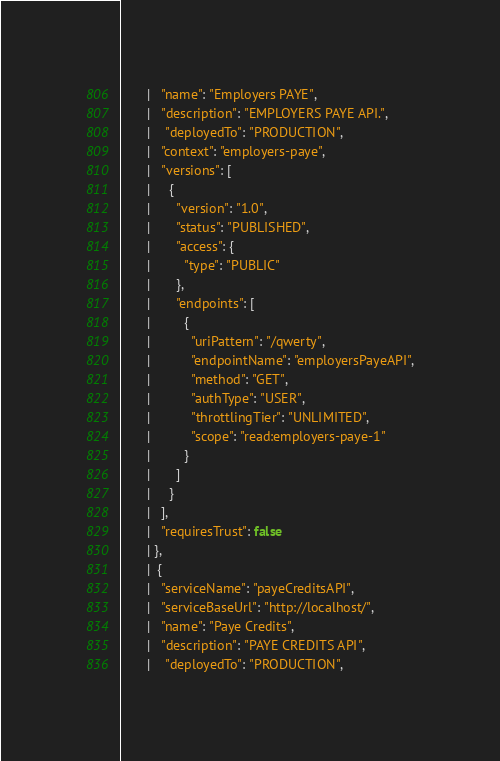<code> <loc_0><loc_0><loc_500><loc_500><_Scala_>       |   "name": "Employers PAYE",
       |   "description": "EMPLOYERS PAYE API.",
       |    "deployedTo": "PRODUCTION",
       |   "context": "employers-paye",
       |   "versions": [
       |     {
       |       "version": "1.0",
       |       "status": "PUBLISHED",
       |       "access": {
       |         "type": "PUBLIC"
       |       },
       |       "endpoints": [
       |         {
       |           "uriPattern": "/qwerty",
       |           "endpointName": "employersPayeAPI",
       |           "method": "GET",
       |           "authType": "USER",
       |           "throttlingTier": "UNLIMITED",
       |           "scope": "read:employers-paye-1"
       |         }
       |       ]
       |     }
       |   ],
       |   "requiresTrust": false
       | },
       |  {
       |   "serviceName": "payeCreditsAPI",
       |   "serviceBaseUrl": "http://localhost/",
       |   "name": "Paye Credits",
       |   "description": "PAYE CREDITS API",
       |    "deployedTo": "PRODUCTION",</code> 